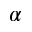<formula> <loc_0><loc_0><loc_500><loc_500>\alpha</formula> 